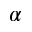<formula> <loc_0><loc_0><loc_500><loc_500>\alpha</formula> 